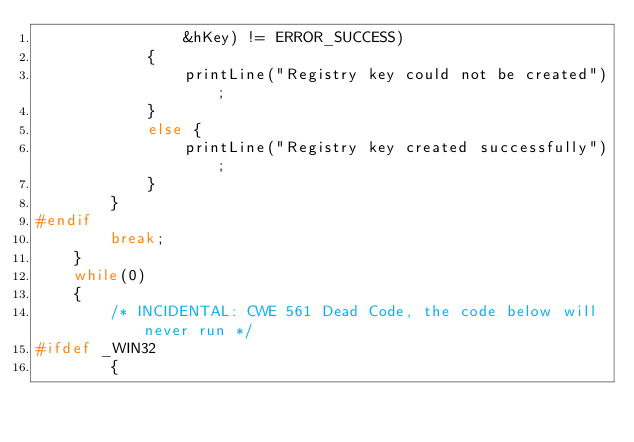Convert code to text. <code><loc_0><loc_0><loc_500><loc_500><_C_>                &hKey) != ERROR_SUCCESS)
            {
                printLine("Registry key could not be created");
            }
            else {
                printLine("Registry key created successfully");
            }
        }
#endif
        break;
    }
    while(0)
    {
        /* INCIDENTAL: CWE 561 Dead Code, the code below will never run */
#ifdef _WIN32
        {</code> 